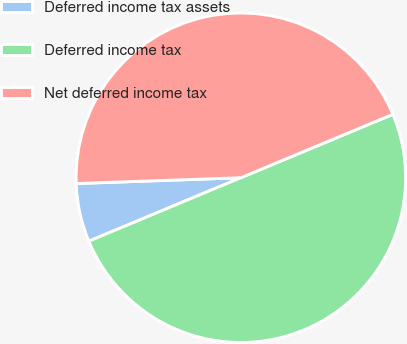Convert chart to OTSL. <chart><loc_0><loc_0><loc_500><loc_500><pie_chart><fcel>Deferred income tax assets<fcel>Deferred income tax<fcel>Net deferred income tax<nl><fcel>5.73%<fcel>50.0%<fcel>44.27%<nl></chart> 